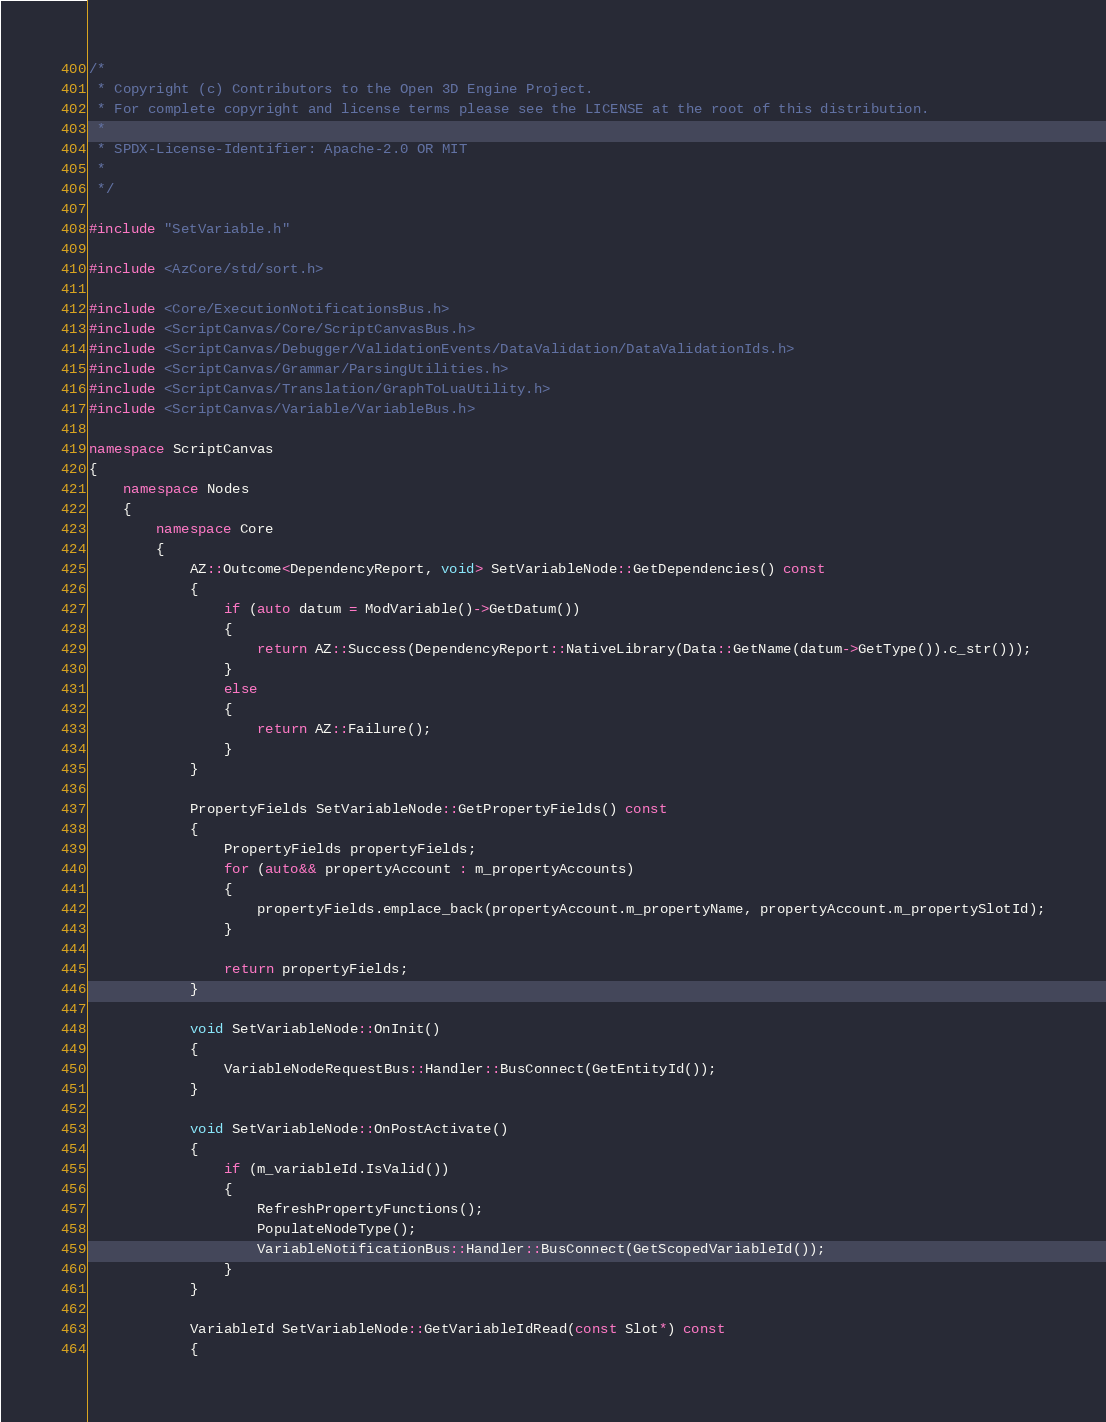<code> <loc_0><loc_0><loc_500><loc_500><_C++_>/*
 * Copyright (c) Contributors to the Open 3D Engine Project.
 * For complete copyright and license terms please see the LICENSE at the root of this distribution.
 *
 * SPDX-License-Identifier: Apache-2.0 OR MIT
 *
 */

#include "SetVariable.h"

#include <AzCore/std/sort.h>

#include <Core/ExecutionNotificationsBus.h>
#include <ScriptCanvas/Core/ScriptCanvasBus.h>
#include <ScriptCanvas/Debugger/ValidationEvents/DataValidation/DataValidationIds.h>
#include <ScriptCanvas/Grammar/ParsingUtilities.h>
#include <ScriptCanvas/Translation/GraphToLuaUtility.h>
#include <ScriptCanvas/Variable/VariableBus.h>

namespace ScriptCanvas
{
    namespace Nodes
    {
        namespace Core
        {
            AZ::Outcome<DependencyReport, void> SetVariableNode::GetDependencies() const
            {
                if (auto datum = ModVariable()->GetDatum())
                {
                    return AZ::Success(DependencyReport::NativeLibrary(Data::GetName(datum->GetType()).c_str()));
                }
                else
                {
                    return AZ::Failure();
                }
            }

            PropertyFields SetVariableNode::GetPropertyFields() const
            {
                PropertyFields propertyFields;
                for (auto&& propertyAccount : m_propertyAccounts)
                {
                    propertyFields.emplace_back(propertyAccount.m_propertyName, propertyAccount.m_propertySlotId);
                }

                return propertyFields;
            }

            void SetVariableNode::OnInit()
            {
                VariableNodeRequestBus::Handler::BusConnect(GetEntityId());
            }

            void SetVariableNode::OnPostActivate()
            {
                if (m_variableId.IsValid())
                {
                    RefreshPropertyFunctions();
                    PopulateNodeType();
                    VariableNotificationBus::Handler::BusConnect(GetScopedVariableId());
                }
            }

            VariableId SetVariableNode::GetVariableIdRead(const Slot*) const
            {</code> 